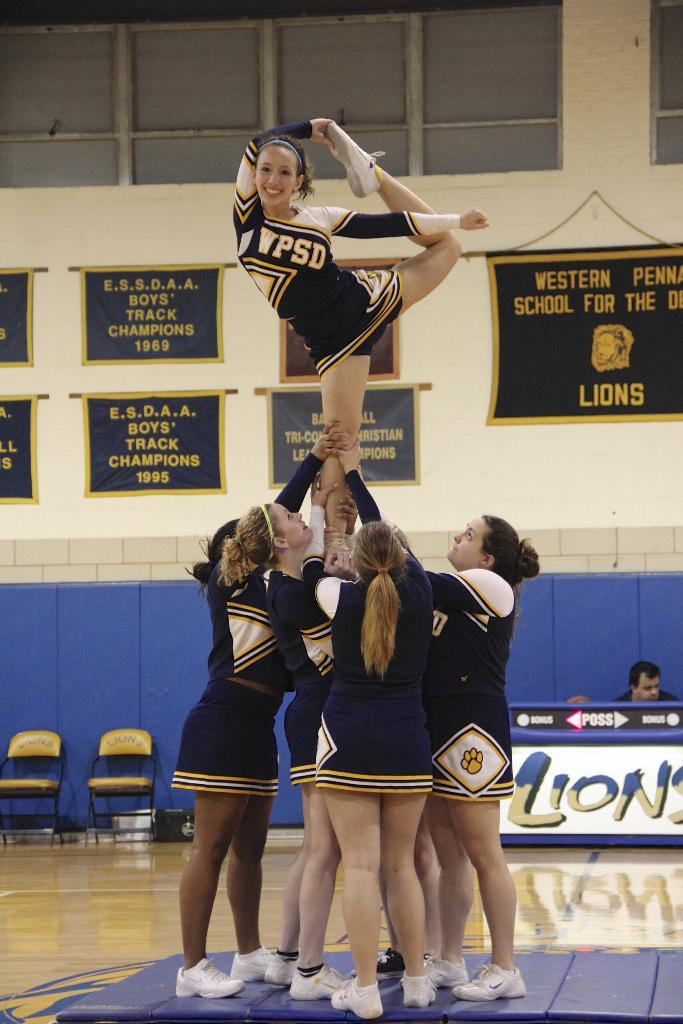<image>
Offer a succinct explanation of the picture presented. A cheerleading team go through their moves in front of banners proclaoming track champions and another which is the school logo. 